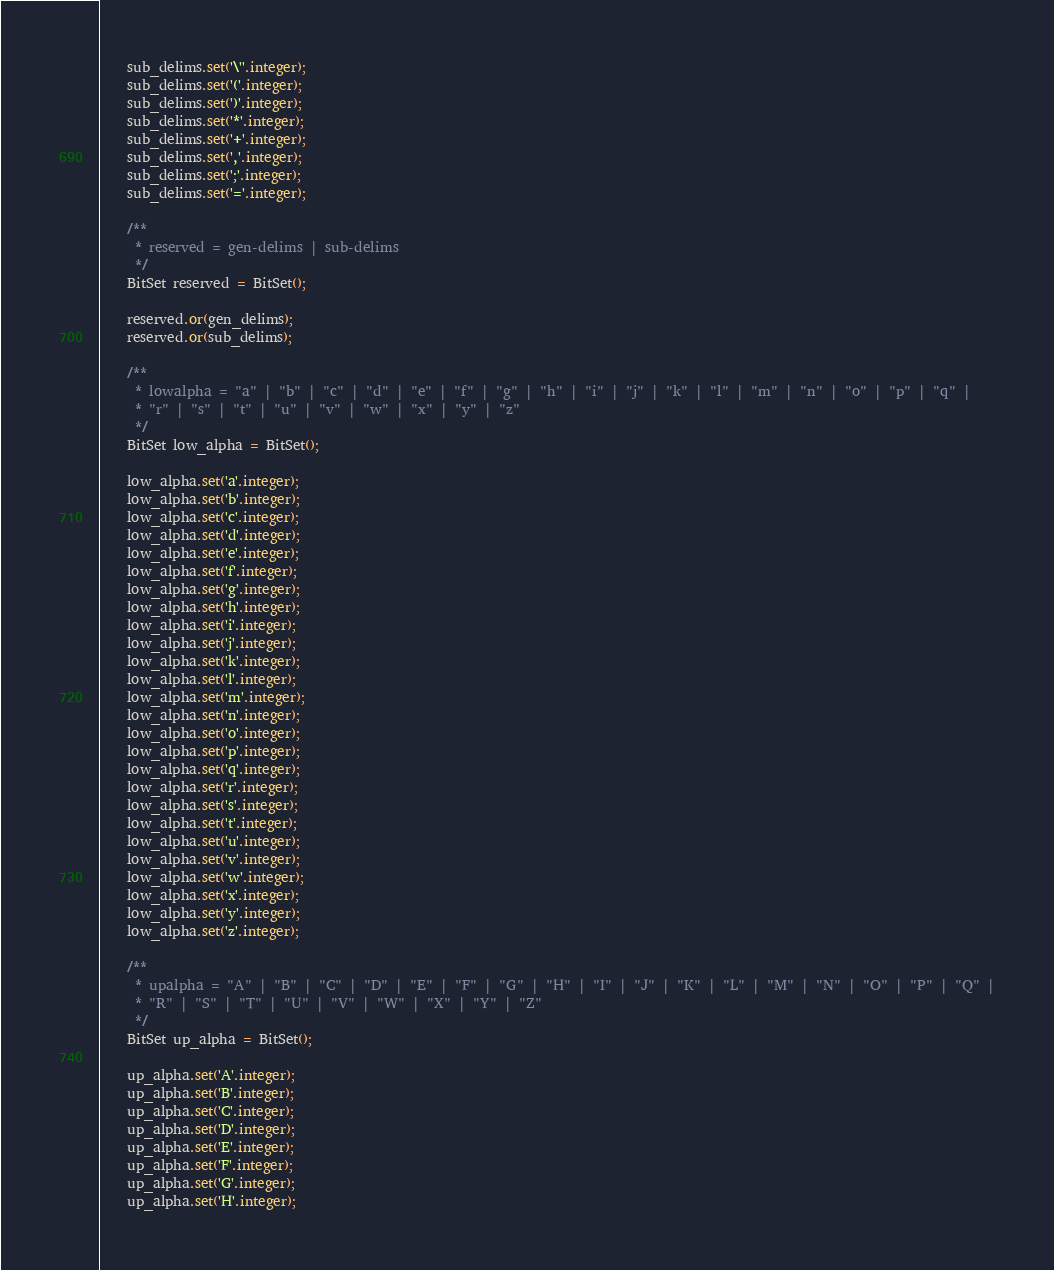<code> <loc_0><loc_0><loc_500><loc_500><_Ceylon_>    sub_delims.set('\''.integer);
    sub_delims.set('('.integer);
    sub_delims.set(')'.integer);
    sub_delims.set('*'.integer);
    sub_delims.set('+'.integer);
    sub_delims.set(','.integer);
    sub_delims.set(';'.integer);
    sub_delims.set('='.integer);

    /**
     * reserved = gen-delims | sub-delims
     */
    BitSet reserved = BitSet();
    
    reserved.or(gen_delims);
    reserved.or(sub_delims);

    /**
     * lowalpha = "a" | "b" | "c" | "d" | "e" | "f" | "g" | "h" | "i" | "j" | "k" | "l" | "m" | "n" | "o" | "p" | "q" |
     * "r" | "s" | "t" | "u" | "v" | "w" | "x" | "y" | "z"
     */
    BitSet low_alpha = BitSet();
    
    low_alpha.set('a'.integer);
    low_alpha.set('b'.integer);
    low_alpha.set('c'.integer);
    low_alpha.set('d'.integer);
    low_alpha.set('e'.integer);
    low_alpha.set('f'.integer);
    low_alpha.set('g'.integer);
    low_alpha.set('h'.integer);
    low_alpha.set('i'.integer);
    low_alpha.set('j'.integer);
    low_alpha.set('k'.integer);
    low_alpha.set('l'.integer);
    low_alpha.set('m'.integer);
    low_alpha.set('n'.integer);
    low_alpha.set('o'.integer);
    low_alpha.set('p'.integer);
    low_alpha.set('q'.integer);
    low_alpha.set('r'.integer);
    low_alpha.set('s'.integer);
    low_alpha.set('t'.integer);
    low_alpha.set('u'.integer);
    low_alpha.set('v'.integer);
    low_alpha.set('w'.integer);
    low_alpha.set('x'.integer);
    low_alpha.set('y'.integer);
    low_alpha.set('z'.integer);

    /**
     * upalpha = "A" | "B" | "C" | "D" | "E" | "F" | "G" | "H" | "I" | "J" | "K" | "L" | "M" | "N" | "O" | "P" | "Q" |
     * "R" | "S" | "T" | "U" | "V" | "W" | "X" | "Y" | "Z"
     */
    BitSet up_alpha = BitSet();
    
    up_alpha.set('A'.integer);
    up_alpha.set('B'.integer);
    up_alpha.set('C'.integer);
    up_alpha.set('D'.integer);
    up_alpha.set('E'.integer);
    up_alpha.set('F'.integer);
    up_alpha.set('G'.integer);
    up_alpha.set('H'.integer);</code> 